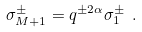Convert formula to latex. <formula><loc_0><loc_0><loc_500><loc_500>\sigma _ { M + 1 } ^ { \pm } = q ^ { \pm 2 \alpha } \sigma _ { 1 } ^ { \pm } \ .</formula> 